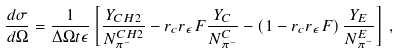Convert formula to latex. <formula><loc_0><loc_0><loc_500><loc_500>\frac { d \sigma } { d \Omega } = \frac { 1 } { \Delta \Omega t \epsilon } \left [ \frac { Y _ { C H 2 } } { N _ { \pi ^ { - } } ^ { C H 2 } } - r _ { c } r _ { \epsilon } F \frac { Y _ { C } } { N _ { \pi ^ { - } } ^ { C } } - \left ( 1 - r _ { c } r _ { \epsilon } F \right ) \frac { Y _ { E } } { N _ { \pi ^ { - } } ^ { E } } \right ] \, ,</formula> 